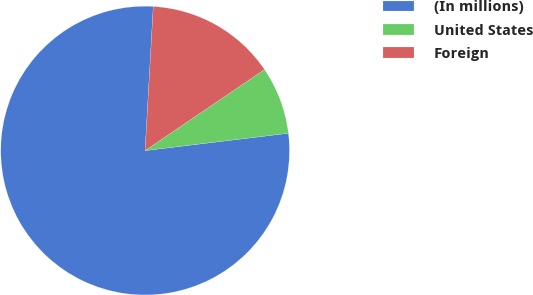Convert chart. <chart><loc_0><loc_0><loc_500><loc_500><pie_chart><fcel>(In millions)<fcel>United States<fcel>Foreign<nl><fcel>77.82%<fcel>7.58%<fcel>14.6%<nl></chart> 